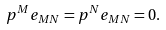<formula> <loc_0><loc_0><loc_500><loc_500>p ^ { M } e _ { M N } = p ^ { N } e _ { M N } = 0 .</formula> 